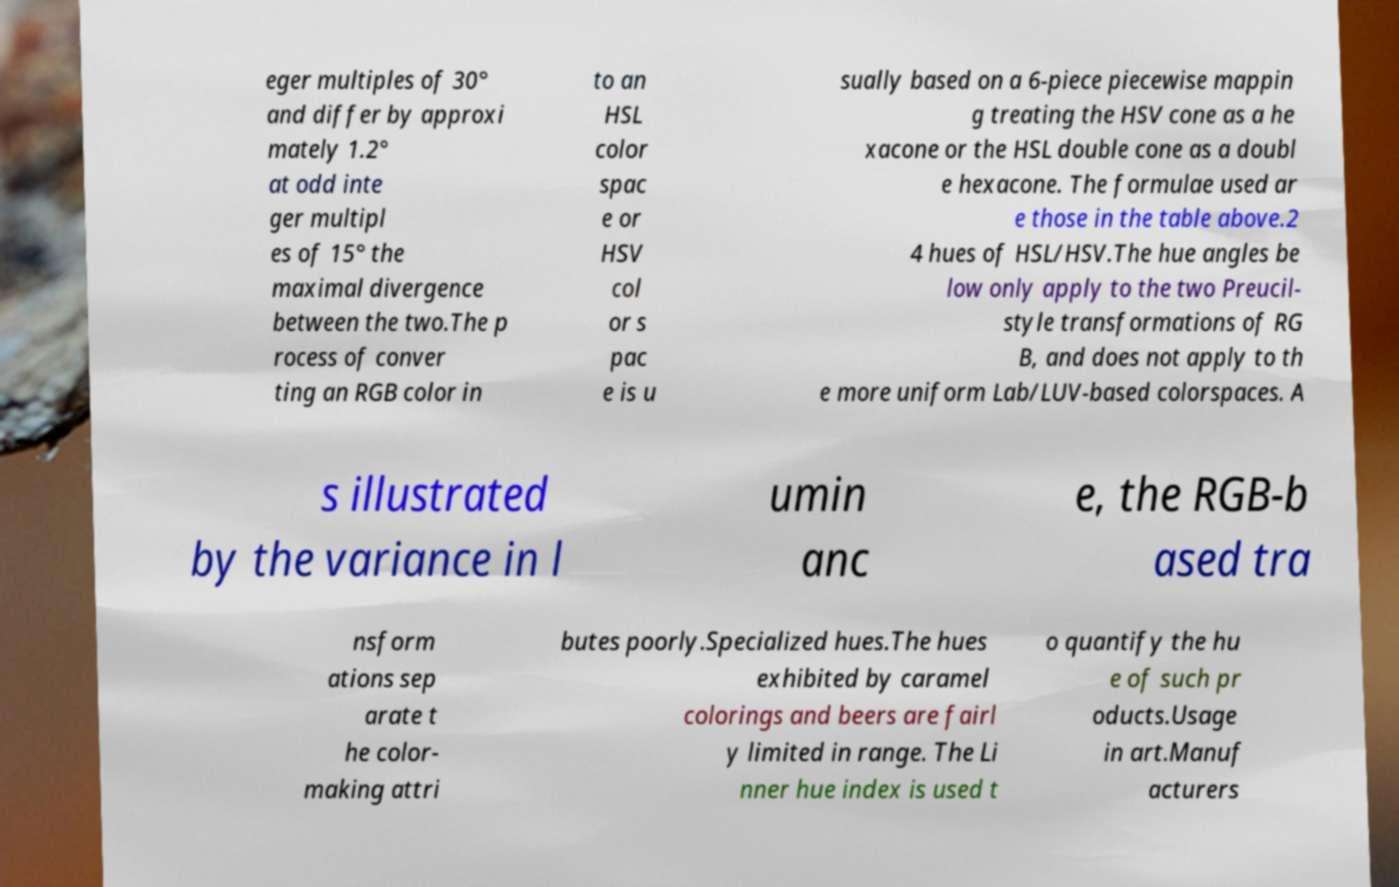What messages or text are displayed in this image? I need them in a readable, typed format. eger multiples of 30° and differ by approxi mately 1.2° at odd inte ger multipl es of 15° the maximal divergence between the two.The p rocess of conver ting an RGB color in to an HSL color spac e or HSV col or s pac e is u sually based on a 6-piece piecewise mappin g treating the HSV cone as a he xacone or the HSL double cone as a doubl e hexacone. The formulae used ar e those in the table above.2 4 hues of HSL/HSV.The hue angles be low only apply to the two Preucil- style transformations of RG B, and does not apply to th e more uniform Lab/LUV-based colorspaces. A s illustrated by the variance in l umin anc e, the RGB-b ased tra nsform ations sep arate t he color- making attri butes poorly.Specialized hues.The hues exhibited by caramel colorings and beers are fairl y limited in range. The Li nner hue index is used t o quantify the hu e of such pr oducts.Usage in art.Manuf acturers 